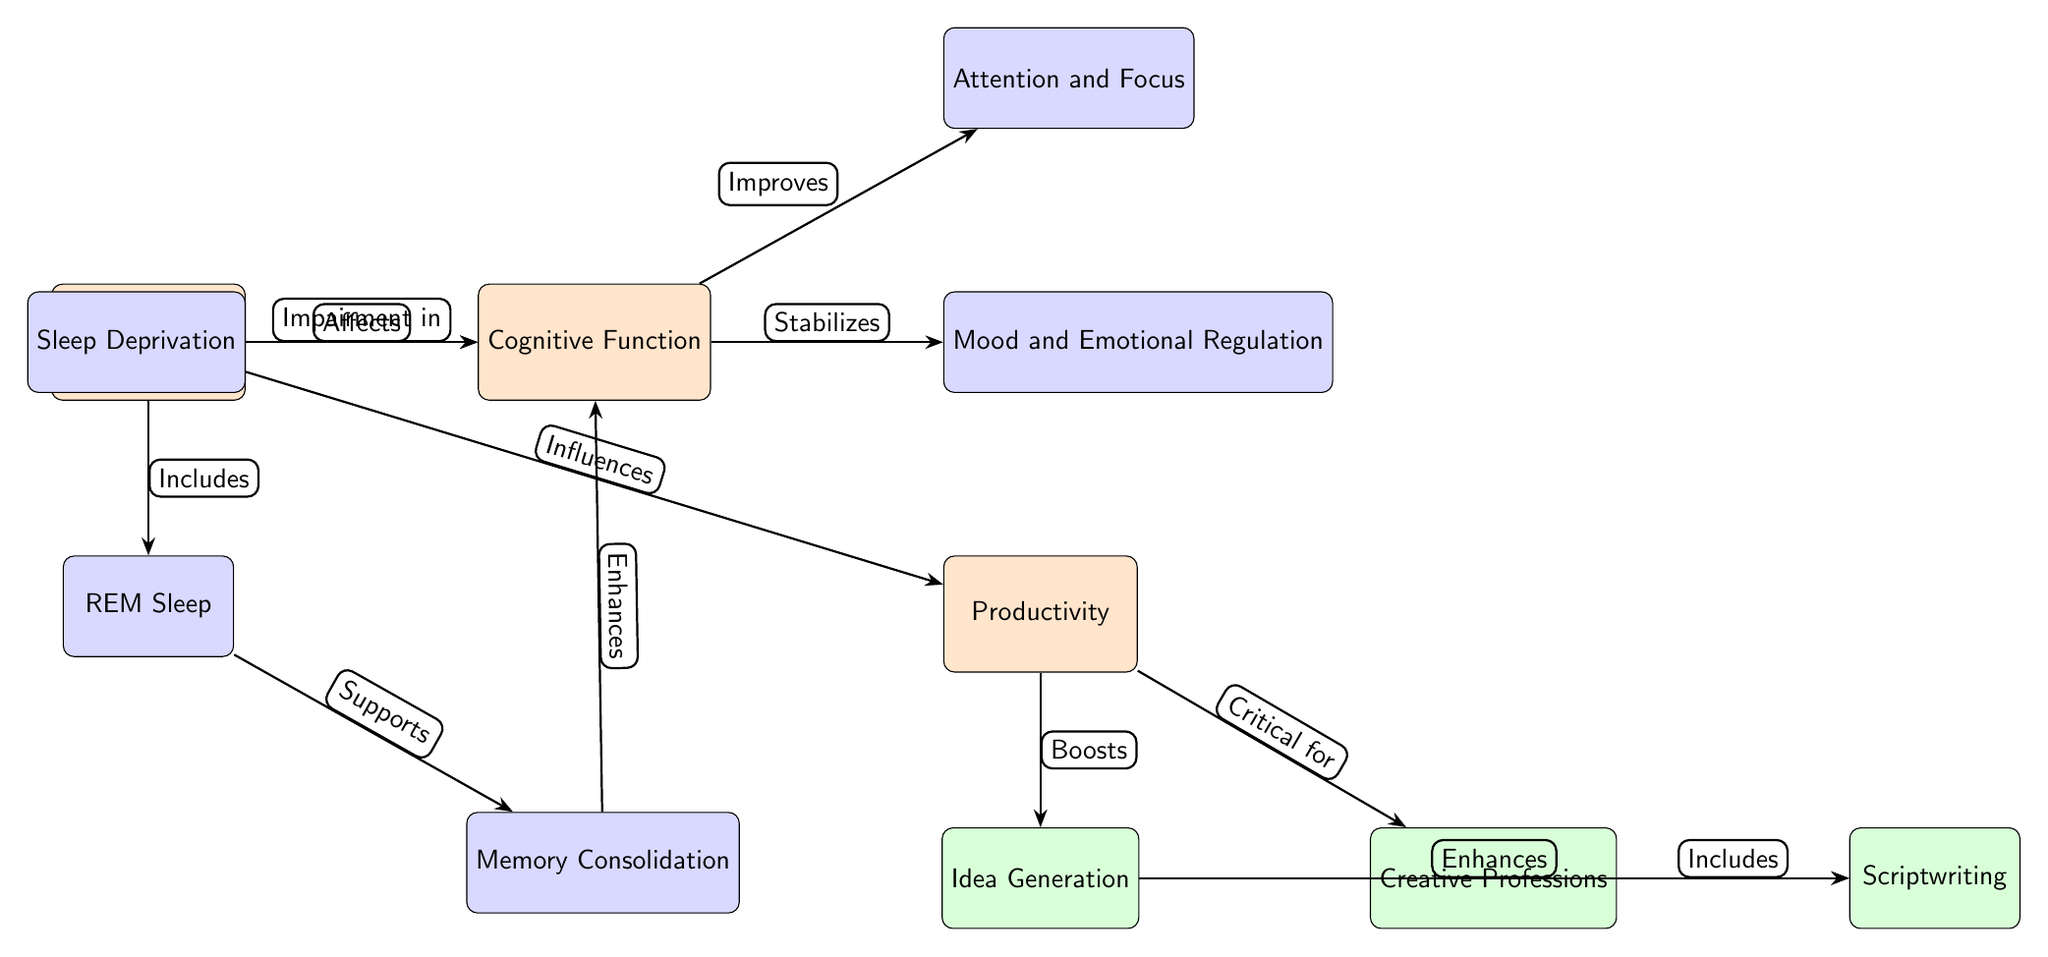What is the main node in the diagram? The main node is positioned at the top, indicating it is the core focus of the diagram. It is labeled "Sleep Patterns."
Answer: Sleep Patterns How many sub-nodes are beneath the main node? There are three sub-nodes directly below the main node: REM Sleep, Memory Consolidation, and Sleep Deprivation.
Answer: 3 What relationship exists between Sleep Patterns and Cognitive Function? The arrow labeled "Affects" indicates a direct relationship where Sleep Patterns influence Cognitive Function.
Answer: Affects Which sub-node enhances Cognitive Function? Memory Consolidation is connected to Cognitive Function by the arrow labeled "Enhances," establishing its role in improvement.
Answer: Memory Consolidation How does Sleep Deprivation impact Cognitive Function? The diagram shows that Sleep Deprivation has an arrow labeled "Impairment in" that leads to Cognitive Function, indicating a negative impact.
Answer: Impairment What critical node does Productivity directly relate to? According to the diagram, Productivity is shown to be "Critical for" Creative Professions in the connections outlined.
Answer: Creative Professions Which node affects both mood and emotional regulation as well as attention and focus? The node Cognitive Function is affected by its relationships with both Mood and Emotional Regulation, and Attention and Focus, showing its central role.
Answer: Cognitive Function What term describes the process linked to Idea Generation? The relationship model illustrates that Idea Generation is "Boosted" by Productivity, reflecting how they interconnect.
Answer: Boosts What does the node Scriptwriting include? The diagram shows that Scriptwriting is an aspect included under Creative Professions, indicating its specific application.
Answer: Scriptwriting 